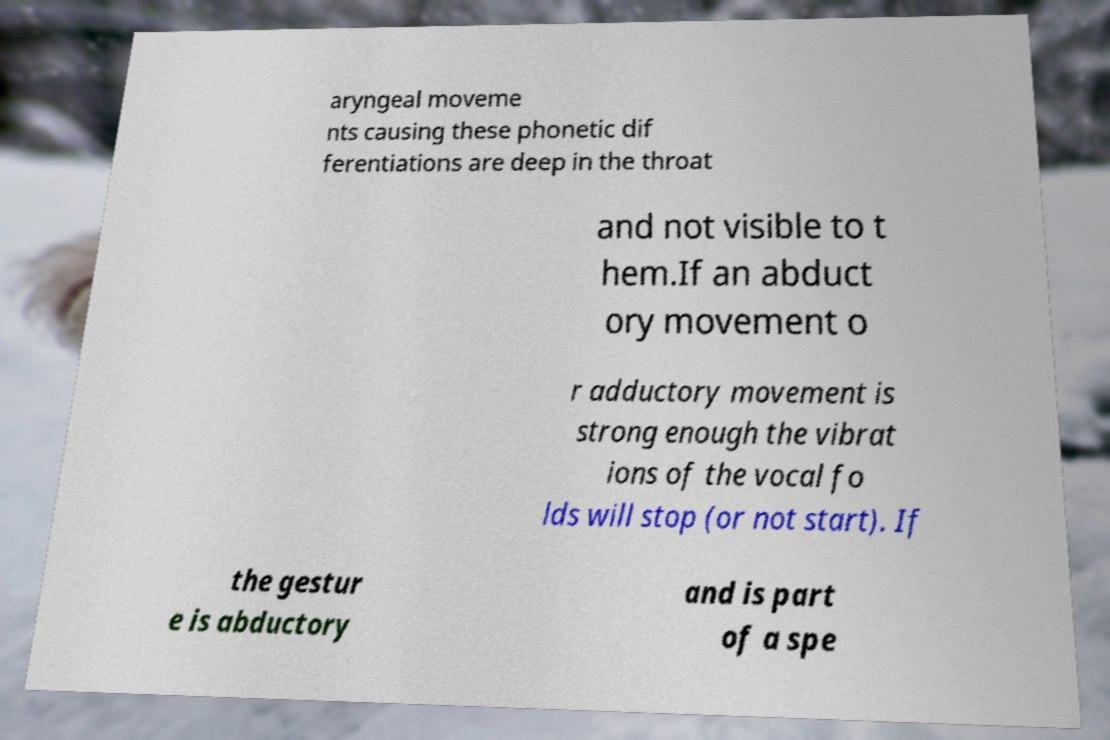There's text embedded in this image that I need extracted. Can you transcribe it verbatim? aryngeal moveme nts causing these phonetic dif ferentiations are deep in the throat and not visible to t hem.If an abduct ory movement o r adductory movement is strong enough the vibrat ions of the vocal fo lds will stop (or not start). If the gestur e is abductory and is part of a spe 